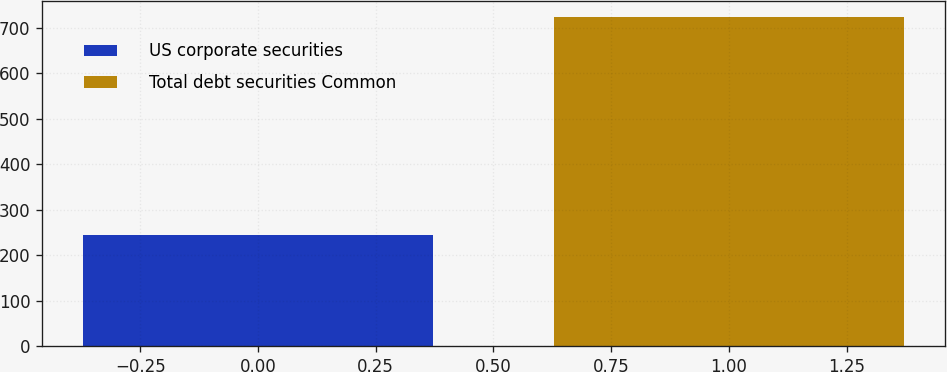<chart> <loc_0><loc_0><loc_500><loc_500><bar_chart><fcel>US corporate securities<fcel>Total debt securities Common<nl><fcel>245<fcel>724<nl></chart> 